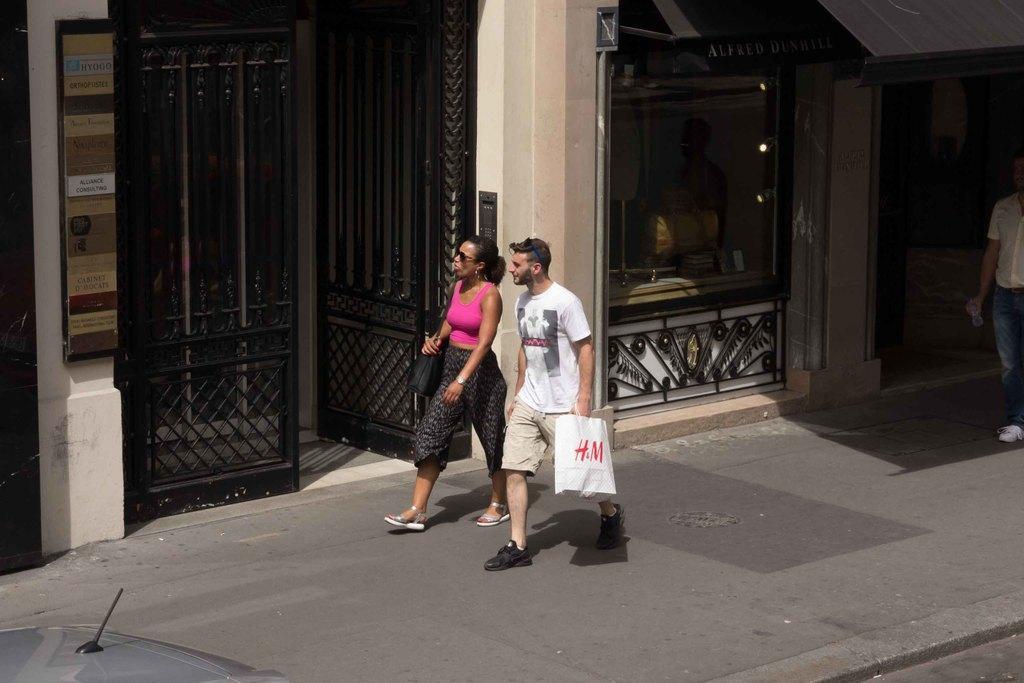Can you describe this image briefly? Here we can see a man and a woman walking on the road and he is holding a bag with his hand. In the background we can see a building, lights, boards, gates, and a person. 